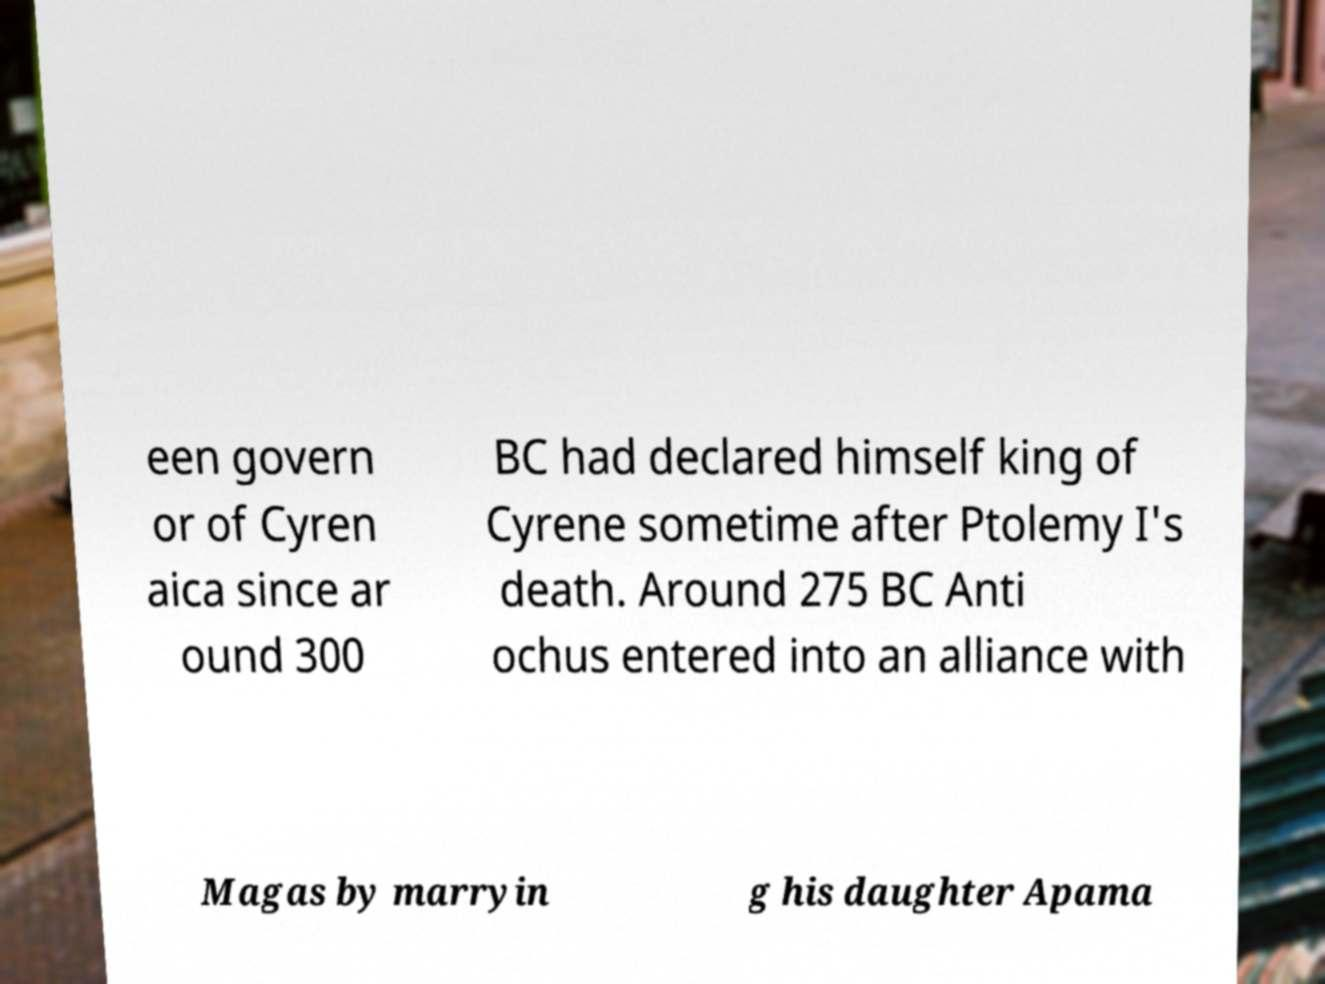What messages or text are displayed in this image? I need them in a readable, typed format. een govern or of Cyren aica since ar ound 300 BC had declared himself king of Cyrene sometime after Ptolemy I's death. Around 275 BC Anti ochus entered into an alliance with Magas by marryin g his daughter Apama 